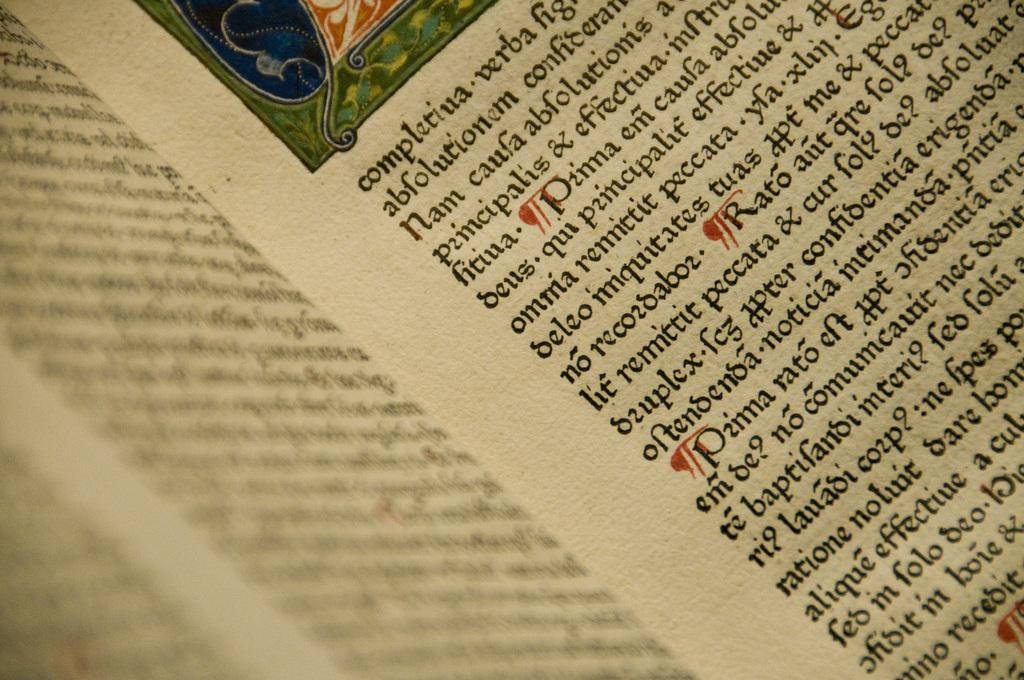<image>
Give a short and clear explanation of the subsequent image. "Completiua" is the first word on the right hand page. 